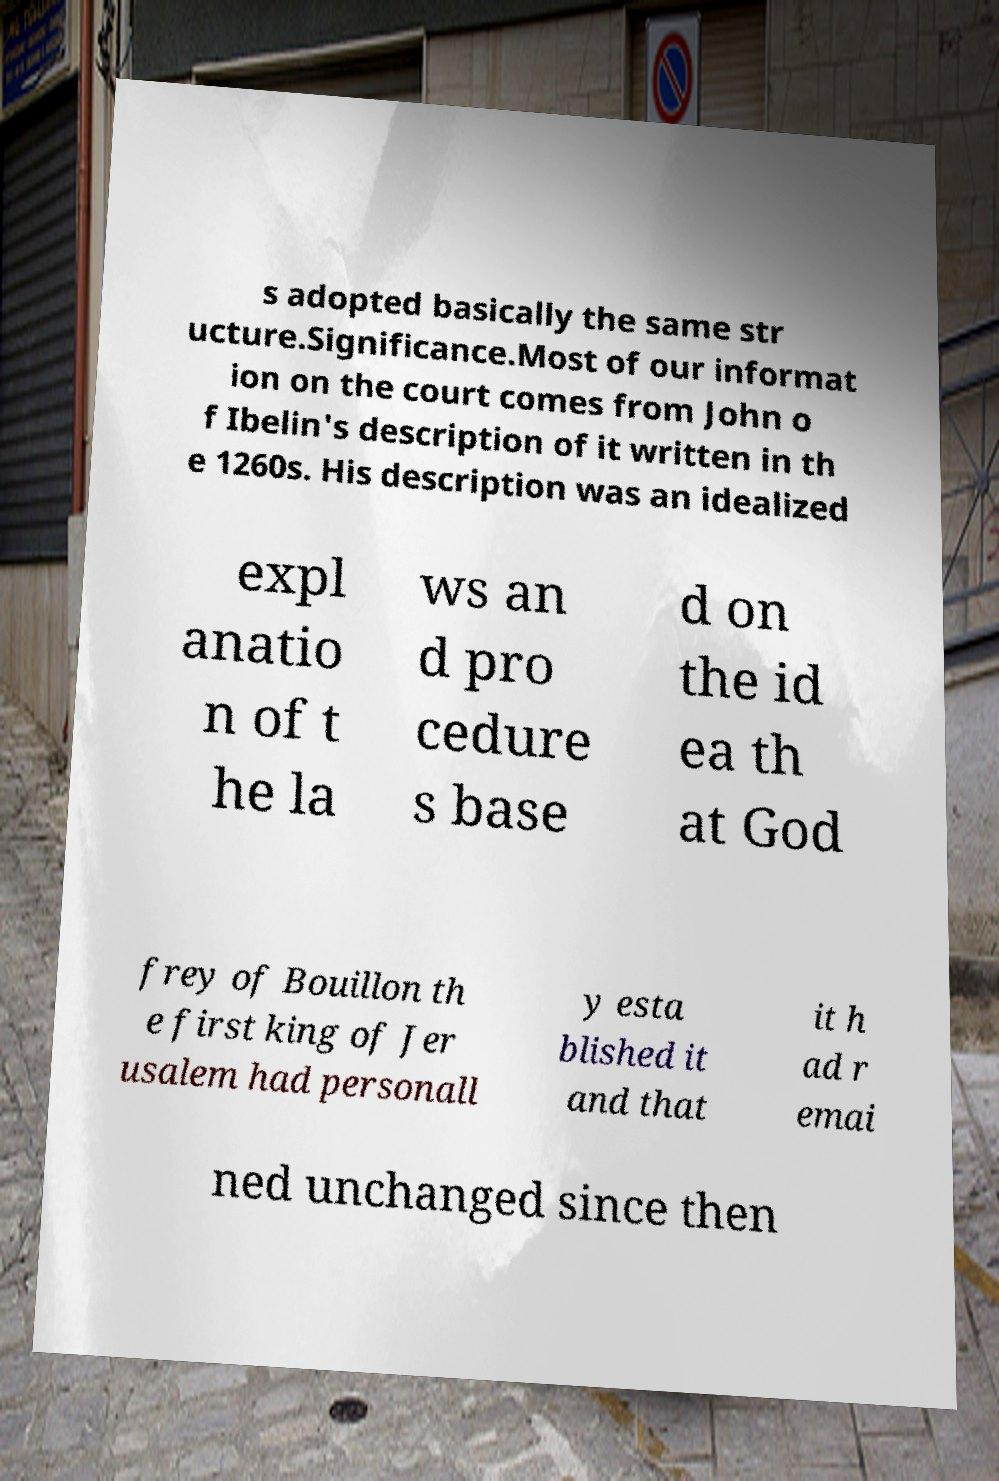For documentation purposes, I need the text within this image transcribed. Could you provide that? s adopted basically the same str ucture.Significance.Most of our informat ion on the court comes from John o f Ibelin's description of it written in th e 1260s. His description was an idealized expl anatio n of t he la ws an d pro cedure s base d on the id ea th at God frey of Bouillon th e first king of Jer usalem had personall y esta blished it and that it h ad r emai ned unchanged since then 